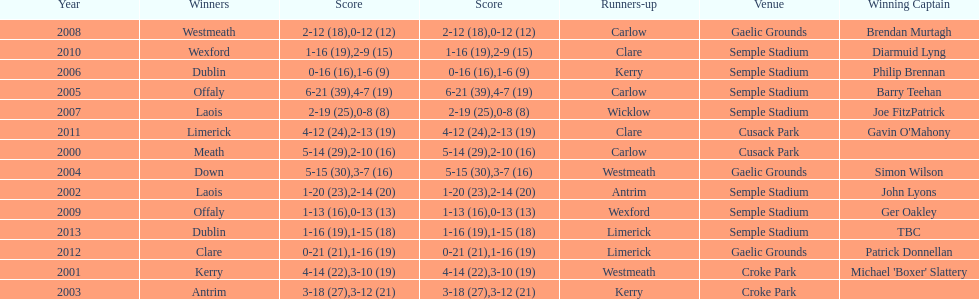In 2013, who emerged as the initial champion? Dublin. 